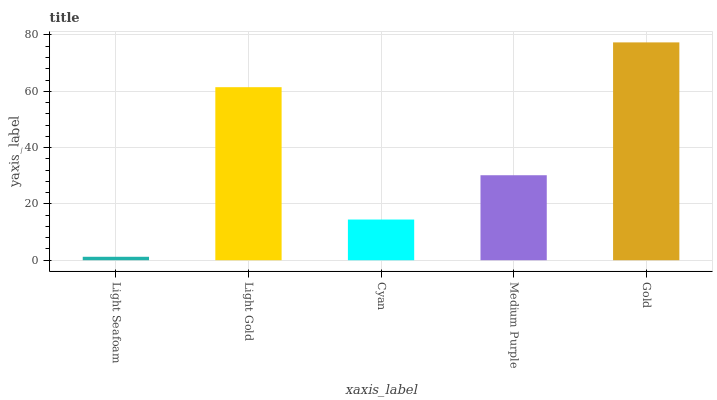Is Light Seafoam the minimum?
Answer yes or no. Yes. Is Gold the maximum?
Answer yes or no. Yes. Is Light Gold the minimum?
Answer yes or no. No. Is Light Gold the maximum?
Answer yes or no. No. Is Light Gold greater than Light Seafoam?
Answer yes or no. Yes. Is Light Seafoam less than Light Gold?
Answer yes or no. Yes. Is Light Seafoam greater than Light Gold?
Answer yes or no. No. Is Light Gold less than Light Seafoam?
Answer yes or no. No. Is Medium Purple the high median?
Answer yes or no. Yes. Is Medium Purple the low median?
Answer yes or no. Yes. Is Cyan the high median?
Answer yes or no. No. Is Light Seafoam the low median?
Answer yes or no. No. 